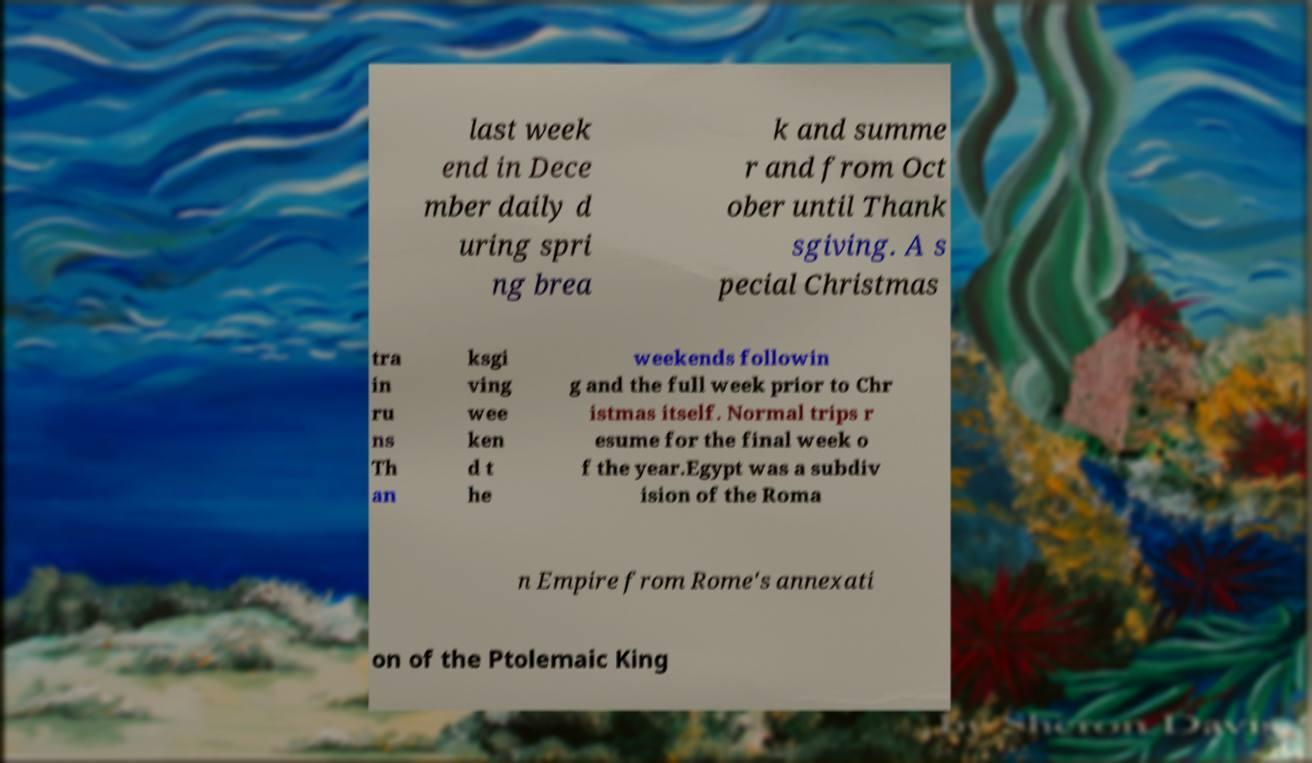For documentation purposes, I need the text within this image transcribed. Could you provide that? last week end in Dece mber daily d uring spri ng brea k and summe r and from Oct ober until Thank sgiving. A s pecial Christmas tra in ru ns Th an ksgi ving wee ken d t he weekends followin g and the full week prior to Chr istmas itself. Normal trips r esume for the final week o f the year.Egypt was a subdiv ision of the Roma n Empire from Rome's annexati on of the Ptolemaic King 